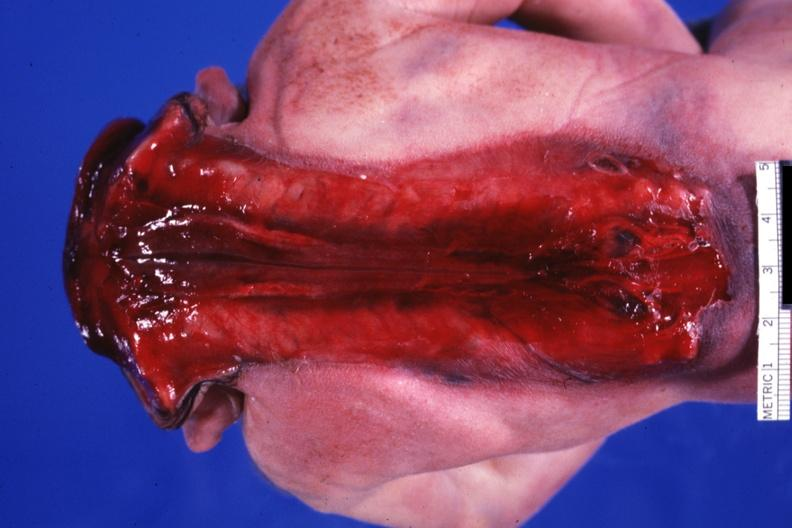s liver with tuberculoid granuloma in glissons with open spine present?
Answer the question using a single word or phrase. No 